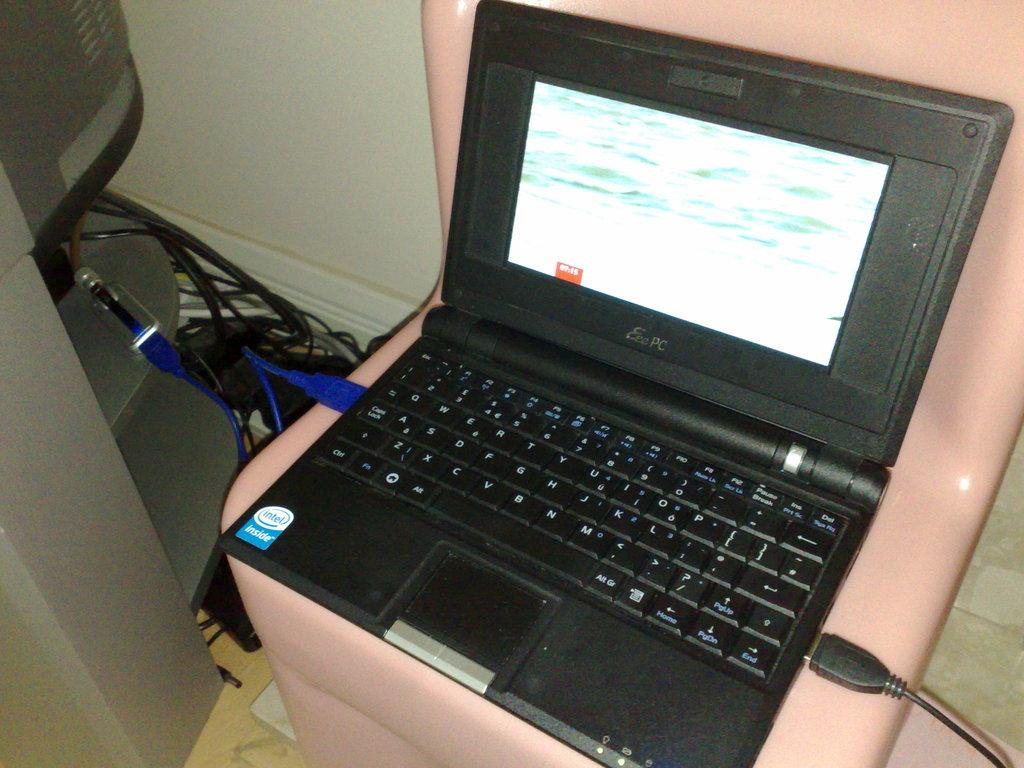Provide a one-sentence caption for the provided image. A laptop with a qwerty keyboard sitting on a chair. 